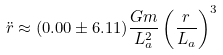Convert formula to latex. <formula><loc_0><loc_0><loc_500><loc_500>\ddot { r } \approx ( 0 . 0 0 \pm 6 . 1 1 ) \frac { G m } { L _ { a } ^ { 2 } } \left ( \frac { r } { L _ { a } } \right ) ^ { 3 }</formula> 